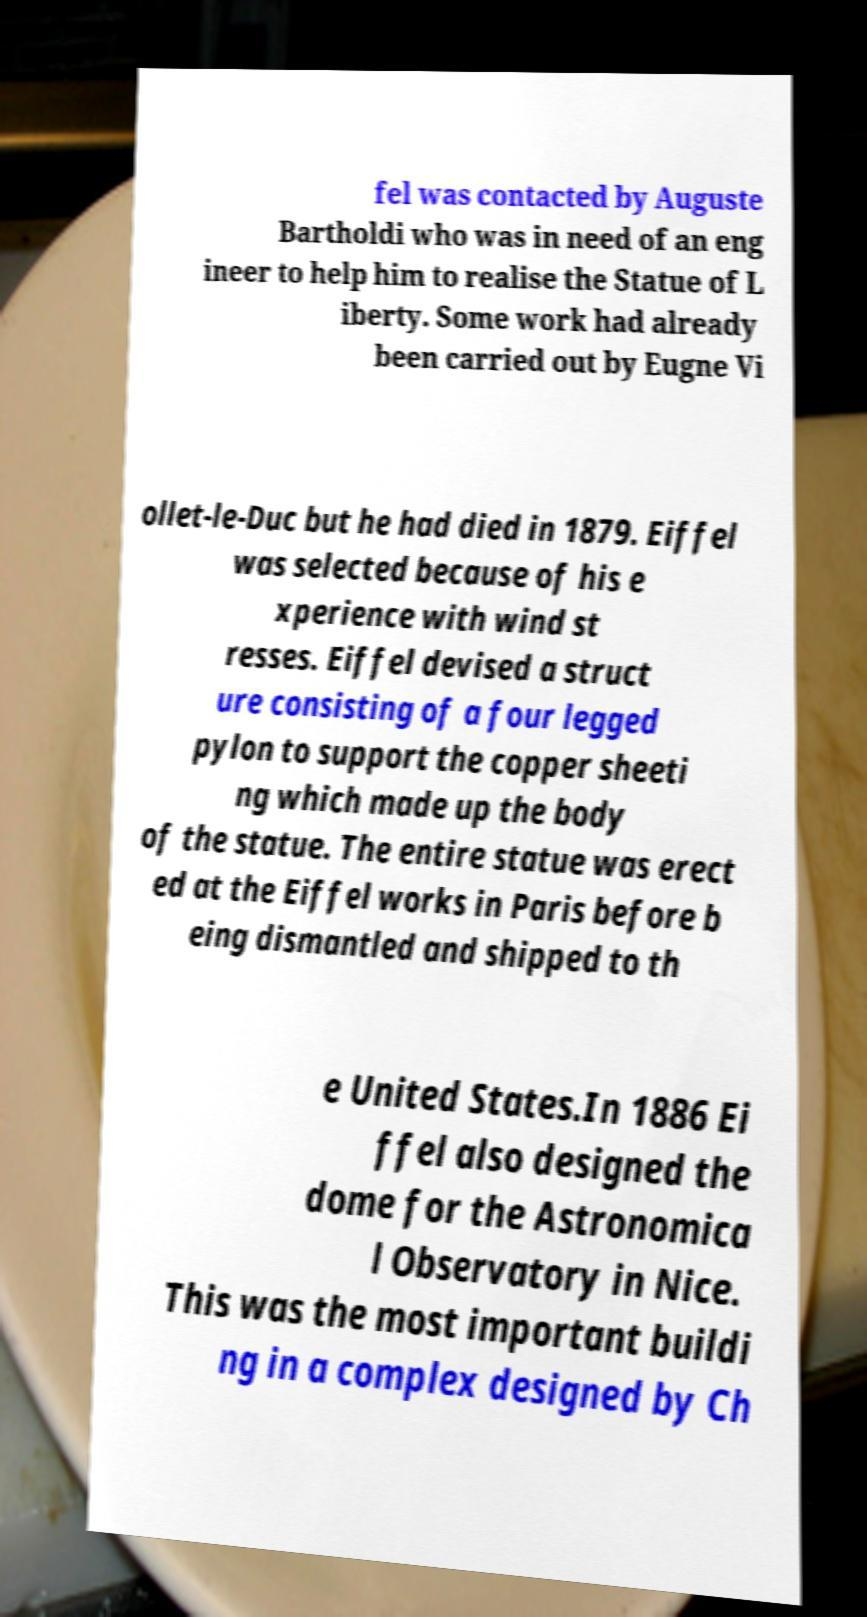What messages or text are displayed in this image? I need them in a readable, typed format. fel was contacted by Auguste Bartholdi who was in need of an eng ineer to help him to realise the Statue of L iberty. Some work had already been carried out by Eugne Vi ollet-le-Duc but he had died in 1879. Eiffel was selected because of his e xperience with wind st resses. Eiffel devised a struct ure consisting of a four legged pylon to support the copper sheeti ng which made up the body of the statue. The entire statue was erect ed at the Eiffel works in Paris before b eing dismantled and shipped to th e United States.In 1886 Ei ffel also designed the dome for the Astronomica l Observatory in Nice. This was the most important buildi ng in a complex designed by Ch 